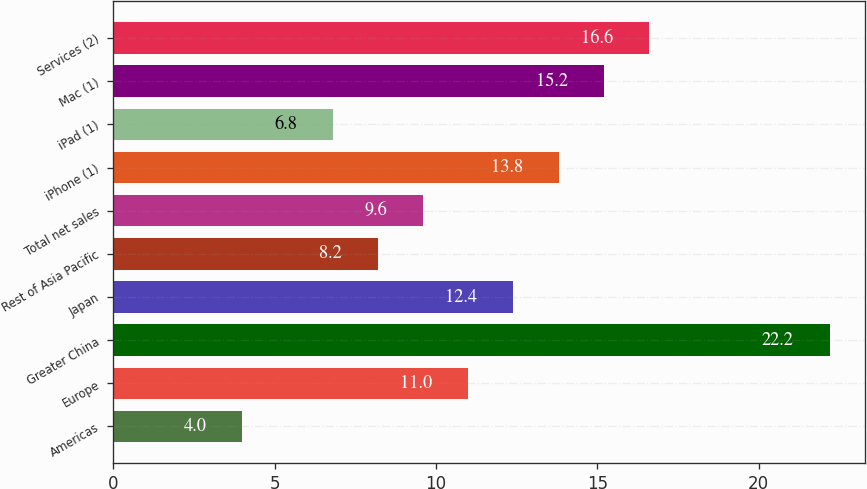Convert chart to OTSL. <chart><loc_0><loc_0><loc_500><loc_500><bar_chart><fcel>Americas<fcel>Europe<fcel>Greater China<fcel>Japan<fcel>Rest of Asia Pacific<fcel>Total net sales<fcel>iPhone (1)<fcel>iPad (1)<fcel>Mac (1)<fcel>Services (2)<nl><fcel>4<fcel>11<fcel>22.2<fcel>12.4<fcel>8.2<fcel>9.6<fcel>13.8<fcel>6.8<fcel>15.2<fcel>16.6<nl></chart> 